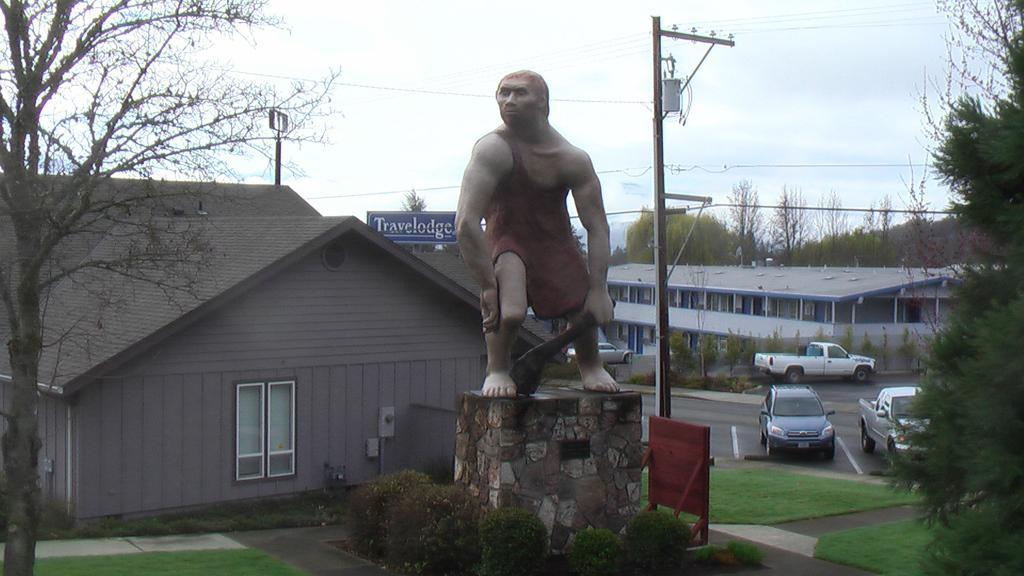Describe this image in one or two sentences. In the center of the image there is a statue on the ground. On the right side of the image we can see buildings, cars and trees. On the left side of the image we can see houses, trees, grass and plants. In the background there is sky and clouds. 